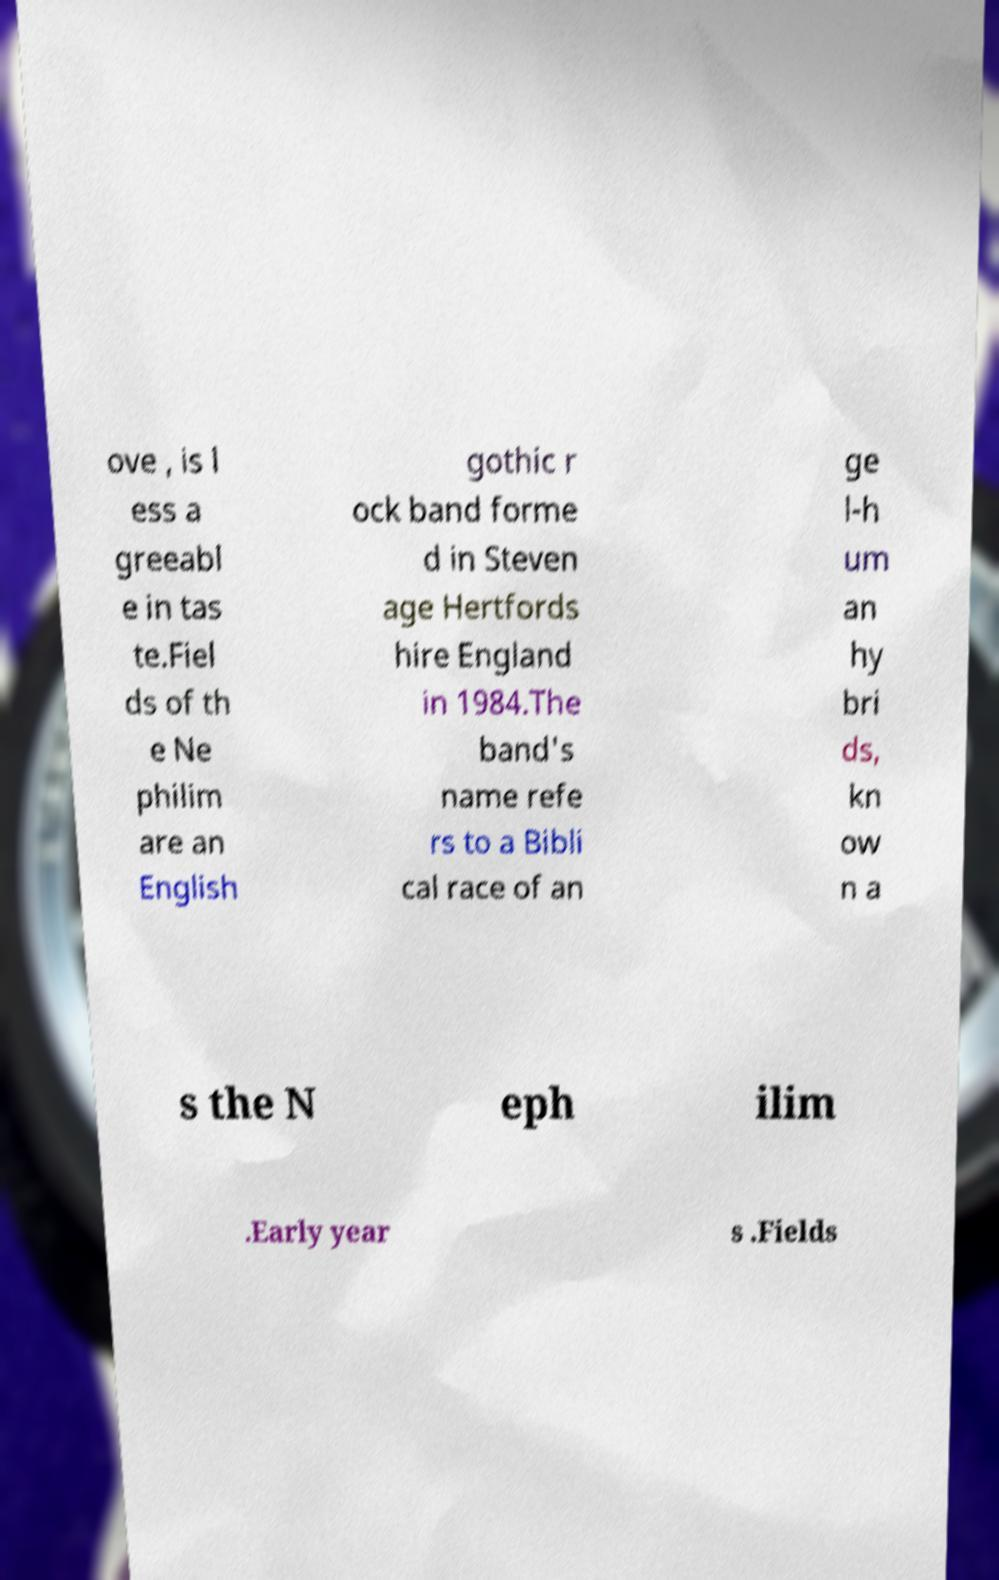I need the written content from this picture converted into text. Can you do that? ove , is l ess a greeabl e in tas te.Fiel ds of th e Ne philim are an English gothic r ock band forme d in Steven age Hertfords hire England in 1984.The band's name refe rs to a Bibli cal race of an ge l-h um an hy bri ds, kn ow n a s the N eph ilim .Early year s .Fields 